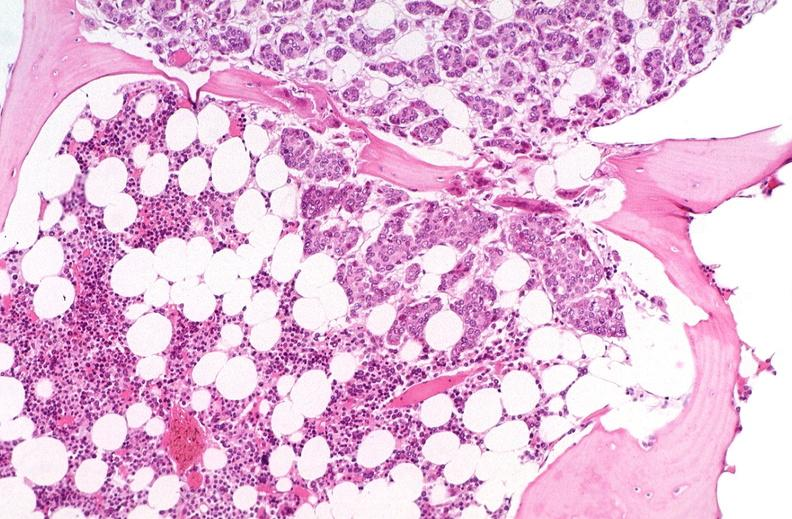what is present?
Answer the question using a single word or phrase. Hematologic 